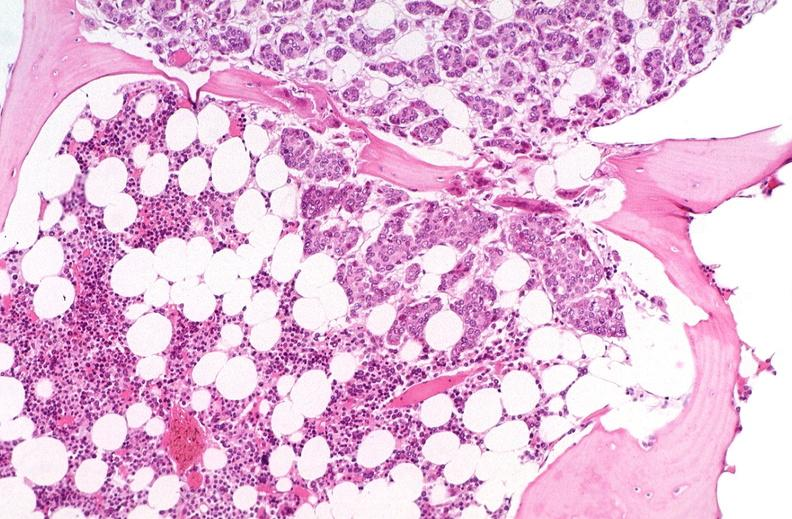what is present?
Answer the question using a single word or phrase. Hematologic 